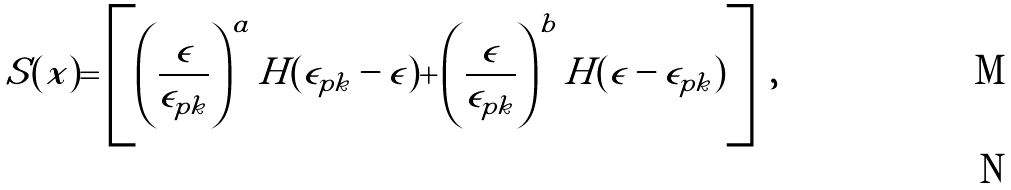Convert formula to latex. <formula><loc_0><loc_0><loc_500><loc_500>S ( x ) = \left [ \left ( \frac { \epsilon } { \epsilon _ { p k } } \right ) ^ { a } H ( \epsilon _ { p k } - \epsilon ) + \left ( \frac { \epsilon } { \epsilon _ { p k } } \right ) ^ { b } H ( \epsilon - \epsilon _ { p k } ) \right ] \ , \\</formula> 